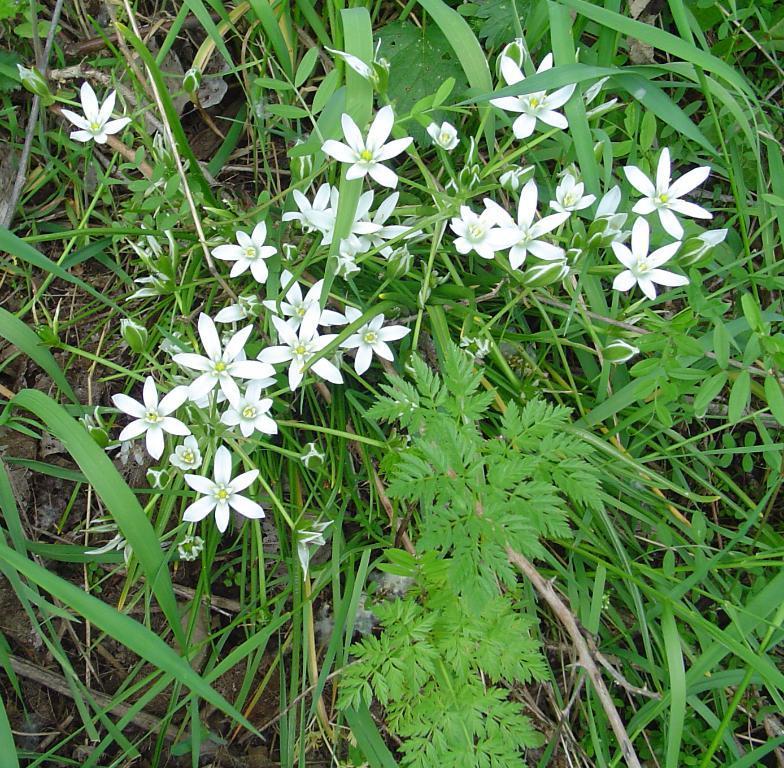In one or two sentences, can you explain what this image depicts? In this image in the center there are flowers and there's grass on the ground. 